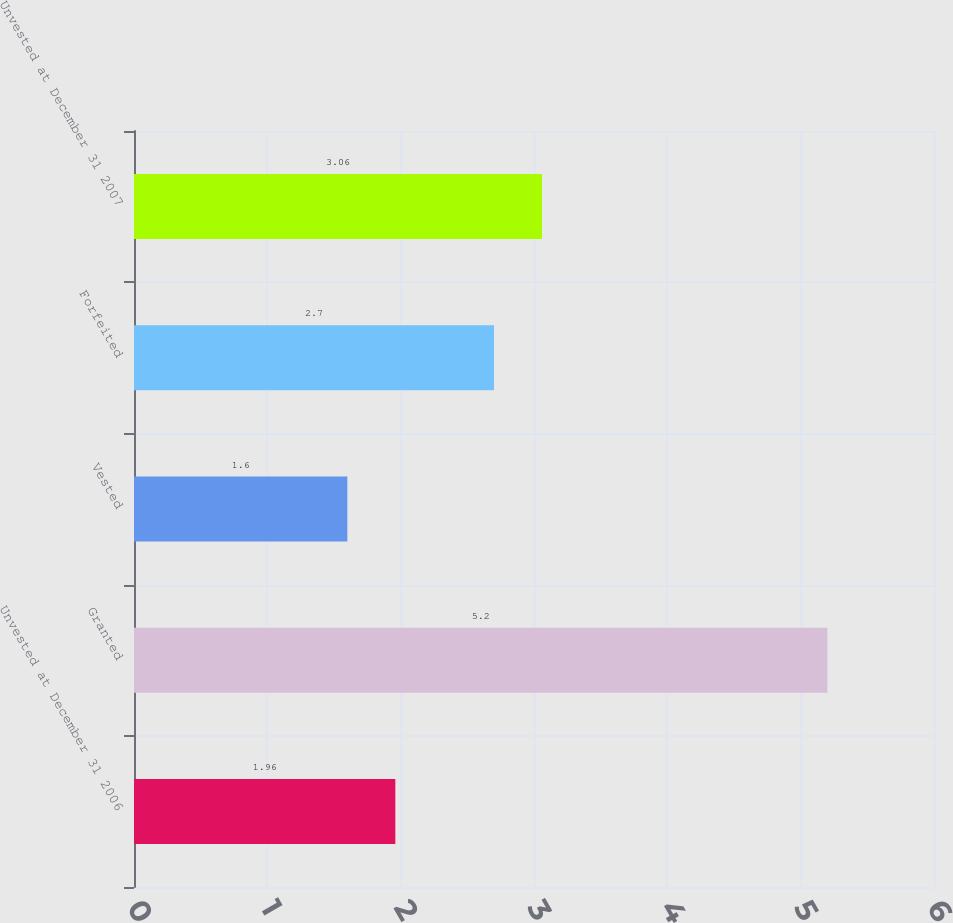Convert chart. <chart><loc_0><loc_0><loc_500><loc_500><bar_chart><fcel>Unvested at December 31 2006<fcel>Granted<fcel>Vested<fcel>Forfeited<fcel>Unvested at December 31 2007<nl><fcel>1.96<fcel>5.2<fcel>1.6<fcel>2.7<fcel>3.06<nl></chart> 